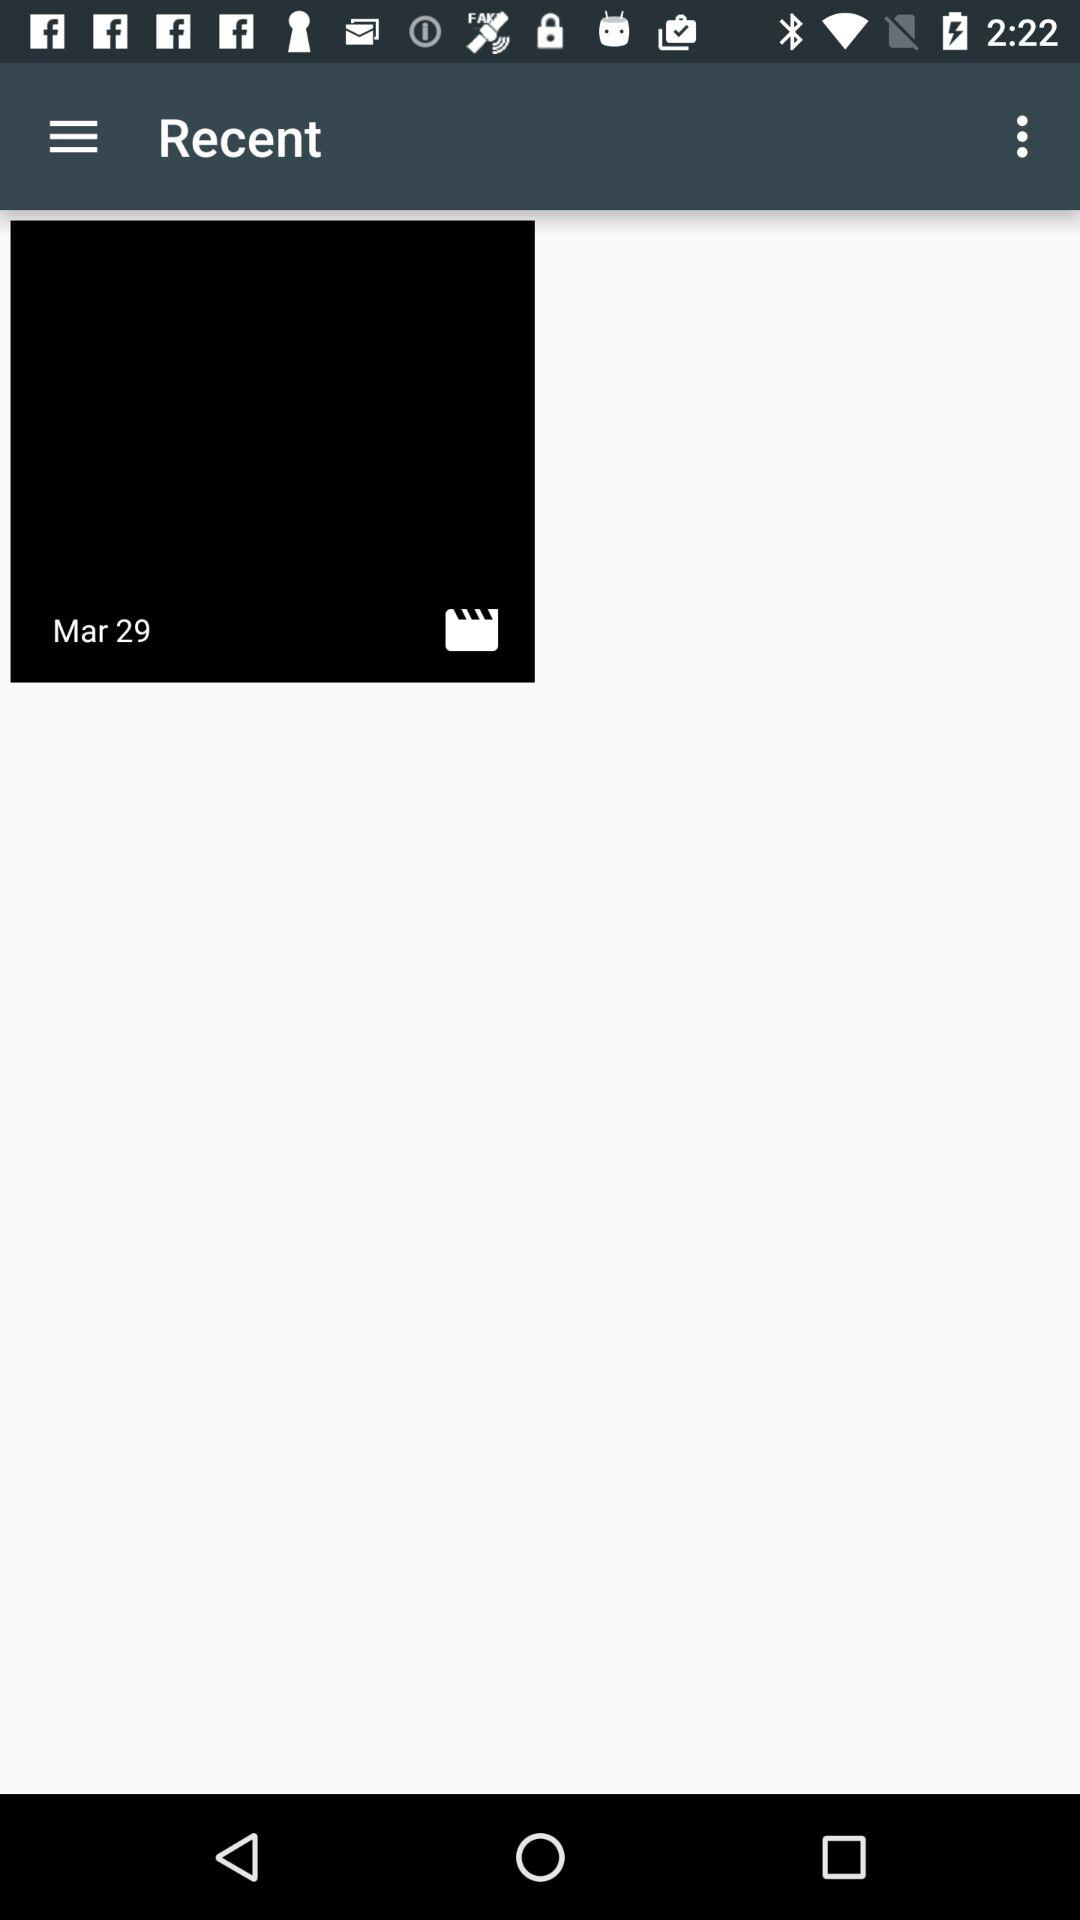What is the date of the media file? The date of the media file is March 29. 